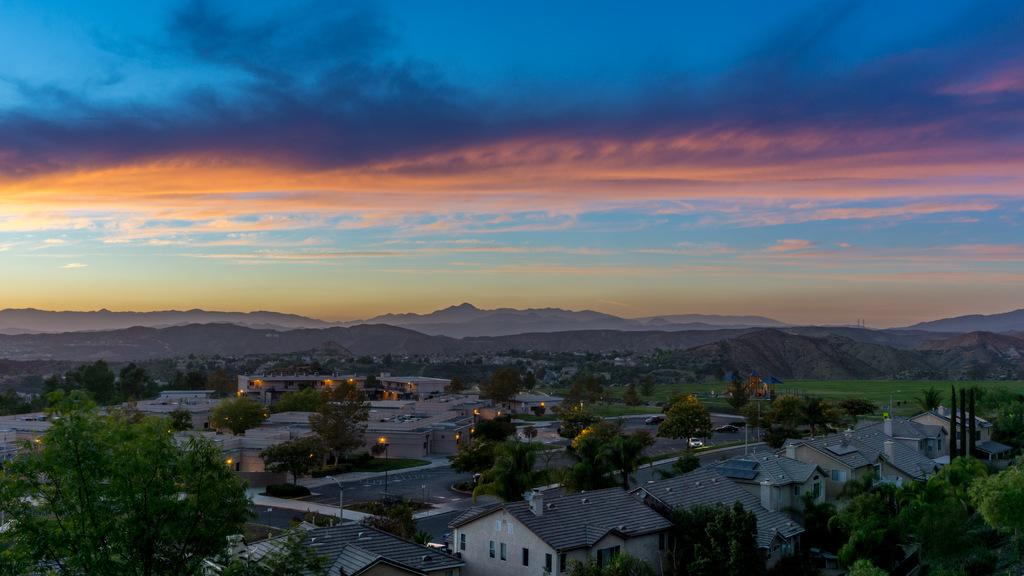What type of structures are present in the image? There are buildings with windows in the image. What can be seen on the buildings? There are lights visible on the buildings. What type of natural elements are present in the image? There are trees and mountains in the image. What is visible in the background of the image? The sky is visible in the background of the image. What is the condition of the sky in the image? Clouds are present in the sky. What type of error can be seen in the image? There is no error present in the image. What type of lettuce is growing on the mountains in the image? There is no lettuce present in the image, and the mountains do not have any vegetation growing on them. 